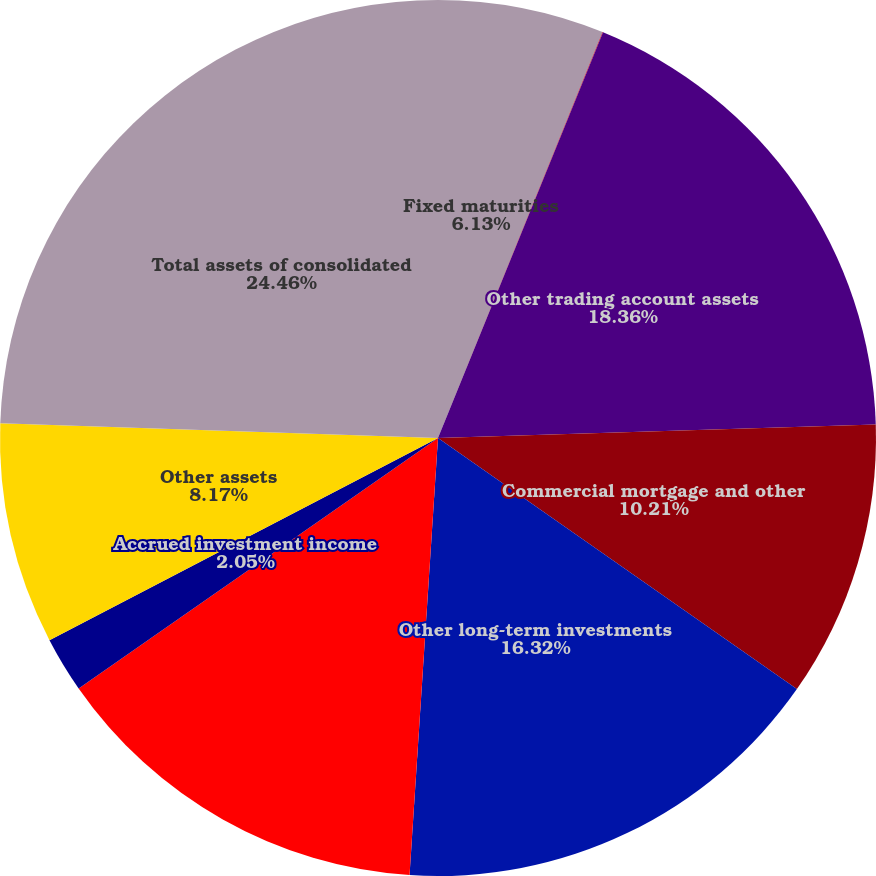<chart> <loc_0><loc_0><loc_500><loc_500><pie_chart><fcel>Fixed maturities<fcel>Trading account assets<fcel>Other trading account assets<fcel>Commercial mortgage and other<fcel>Other long-term investments<fcel>Cash and cash equivalents<fcel>Accrued investment income<fcel>Other assets<fcel>Total assets of consolidated<nl><fcel>6.13%<fcel>0.02%<fcel>18.36%<fcel>10.21%<fcel>16.32%<fcel>14.28%<fcel>2.05%<fcel>8.17%<fcel>24.47%<nl></chart> 